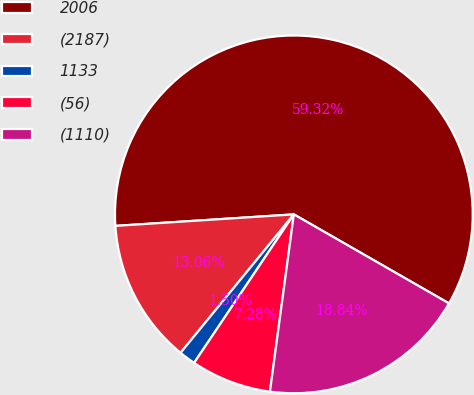<chart> <loc_0><loc_0><loc_500><loc_500><pie_chart><fcel>2006<fcel>(2187)<fcel>1133<fcel>(56)<fcel>(1110)<nl><fcel>59.31%<fcel>13.06%<fcel>1.5%<fcel>7.28%<fcel>18.84%<nl></chart> 